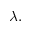Convert formula to latex. <formula><loc_0><loc_0><loc_500><loc_500>\lambda .</formula> 